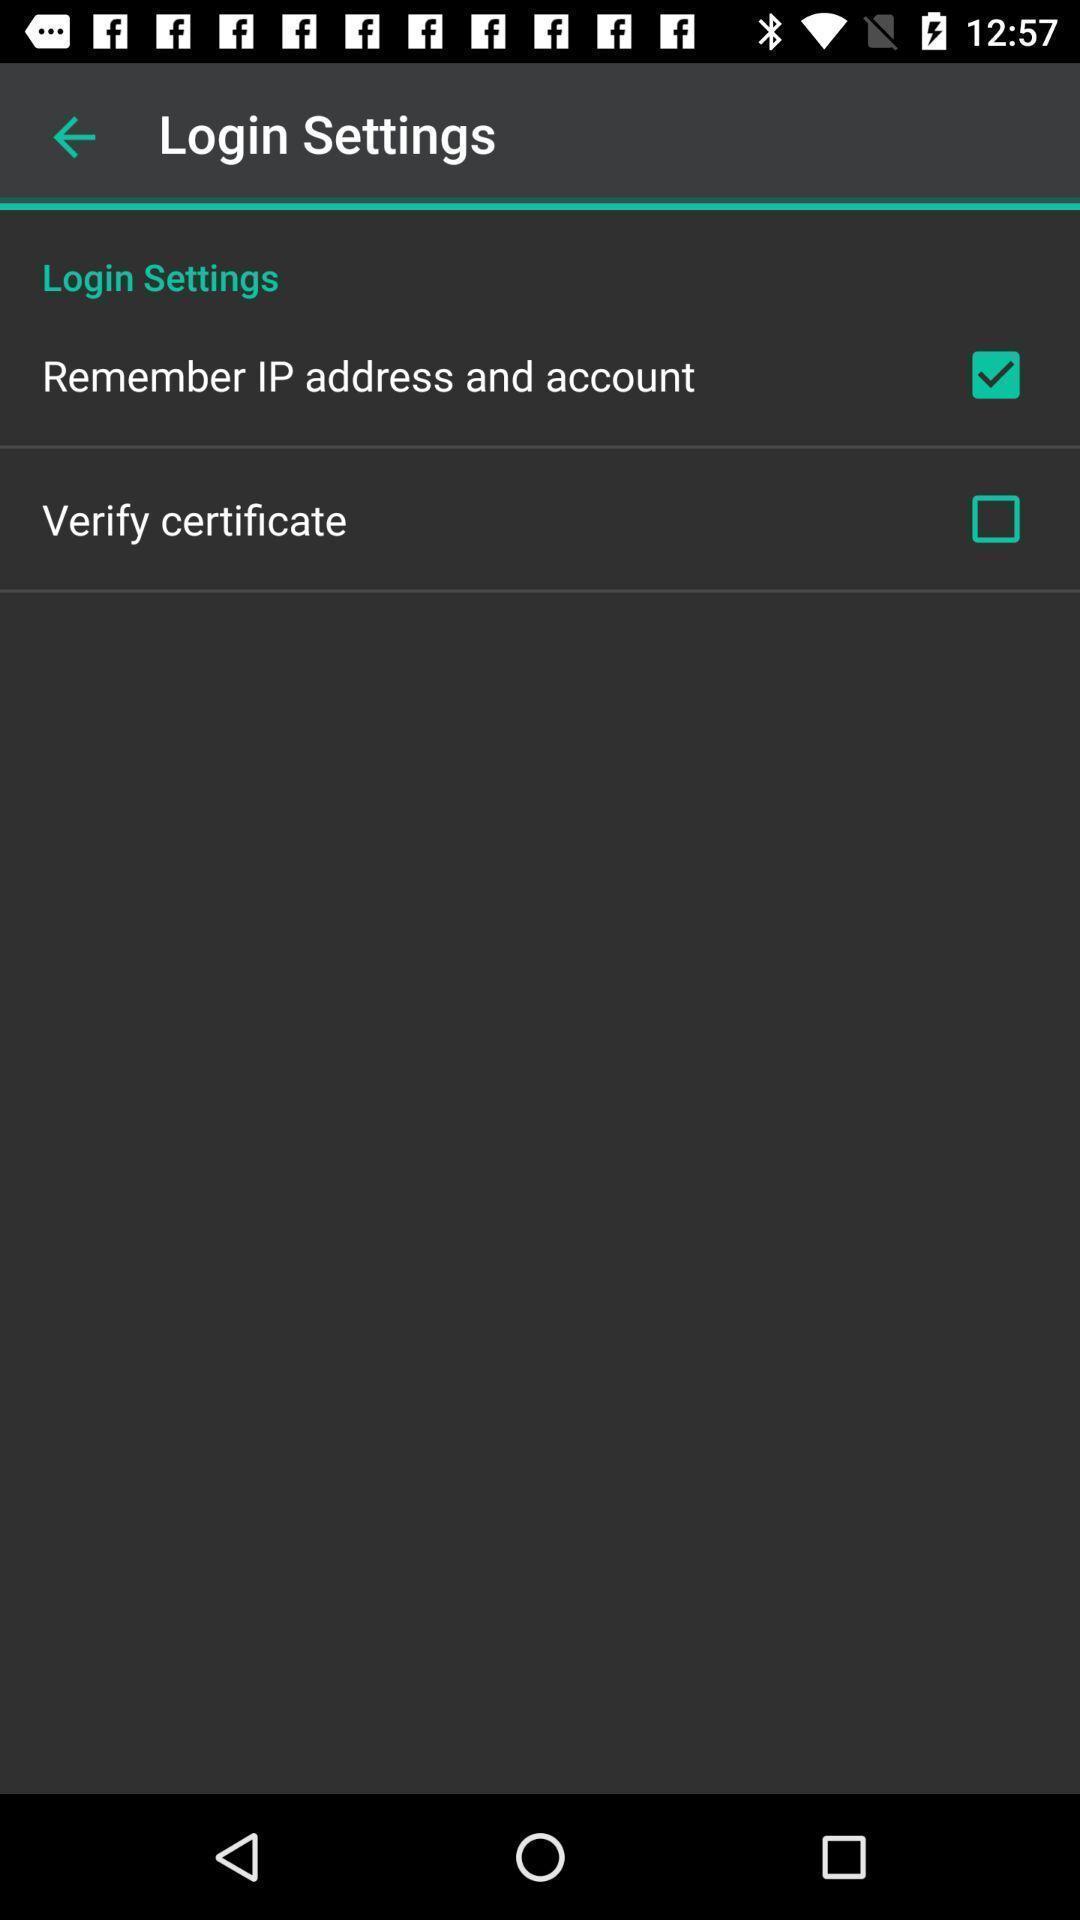Provide a textual representation of this image. Settings page with various options. 